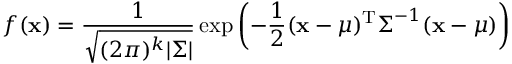<formula> <loc_0><loc_0><loc_500><loc_500>f ( x ) = { \frac { 1 } { \sqrt { ( 2 \pi ) ^ { k } | { \Sigma } | } } } \exp \left ( - { \frac { 1 } { 2 } } ( x - { \mu } ) ^ { T } { \Sigma } ^ { - 1 } ( { x } - { \mu } ) \right )</formula> 